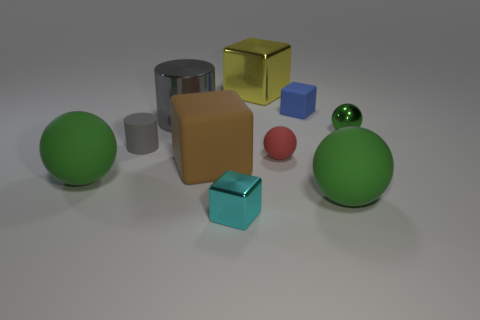Can you describe the lighting in the scene? How does it contribute to the overall mood? The image has a fairly soft and diffused lighting setup with no harsh shadows, providing a calm and neutral mood. It also accentuates the colors and textures of objects and highlights the reflective properties of the metallic items.  Are there any patterns or symmetries in the arrangement of the objects? While there isn't a strict symmetry, there is a balanced distribution of objects. The spherical objects are placed at both ends, and there is an assortment of cubes and cylinders in the center, creating a harmonious and evenly spaced layout. 